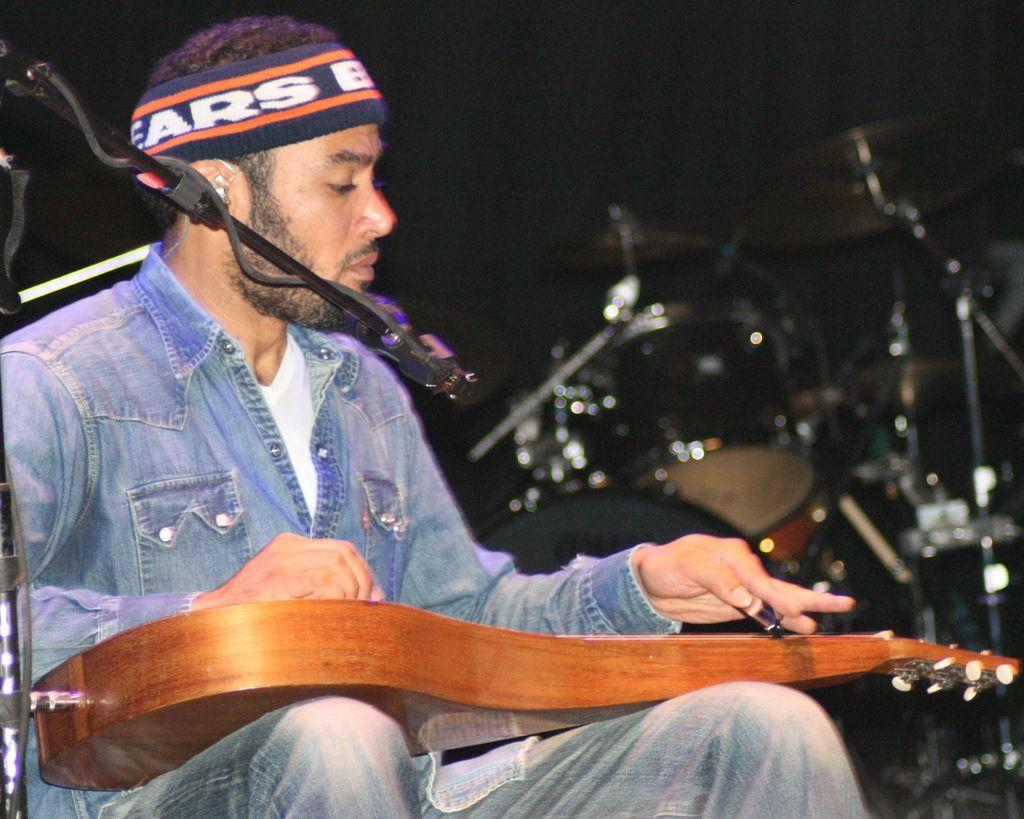What is the main subject of the image? There is a man in the image. What is the man holding in the image? The man is holding a guitar. What other object can be seen in the image? There is a microphone (mic) in the image. What is the zephyr's reaction to the aftermath of the performance in the image? There is no mention of a zephyr or any performance in the image, so it is not possible to answer this question. 